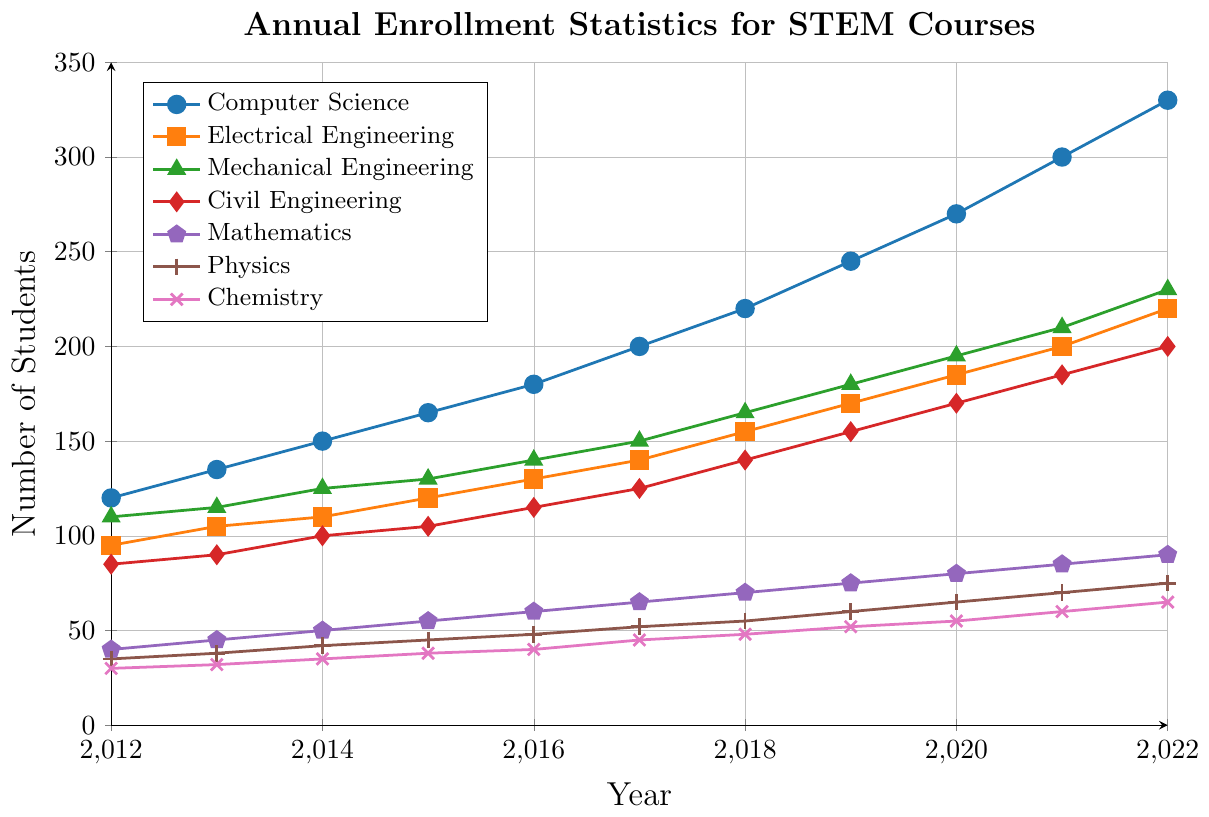Which course had the highest enrollment in 2022? By looking at the line corresponding to 2022, the line for Computer Science is the highest.
Answer: Computer Science How many more students enrolled in Computer Science than in Civil Engineering in 2022? In 2022, Computer Science had 330 students and Civil Engineering had 200 students. The difference is 330 - 200.
Answer: 130 Which course had the smallest increase in enrollment between 2012 and 2022? To determine the smallest increase, we compare the enrollment difference from 2012 to 2022 for all courses. Chemistry increased from 30 to 65, a 35-student increase, which is the smallest.
Answer: Chemistry What's the total enrollment for all courses in 2016? Sum the enrollment numbers for all courses in 2016: 180 (CS) + 130 (EE) + 140 (ME) + 115 (CE) + 60 (Math) + 48 (Physics) + 40 (Chemistry) = 713.
Answer: 713 Which course showed the most consistent increase in student enrollment over the years? By observing the plot lines, the Mathematics course shows a steady, consistent, and gradual increase each year from 2012 to 2022 with no spikes or drops.
Answer: Mathematics How many students were enrolled in Physics in 2020 compared to 2014? In 2020, Physics had 65 students, and in 2014, it had 42 students.
Answer: 65 Was there any year when enrollment in Electrical Engineering was equal to or less than 100? Observe the plot line for Electrical Engineering and see that in 2013 (105), the enrollment was closest but not below or equal to 100.
Answer: No What was the average enrollment for Mechanical Engineering from 2012 to 2022? Summing the Mechanical Engineering enrollment numbers from 2012 to 2022: 110 + 115 + 125 + 130 + 140 + 150 + 165 + 180 + 195 + 210 + 230 = 1750. Dividing by 11 years gives 1750 / 11.
Answer: ~159 Between 2012 and 2015, which course had the highest enrollment growth rate? Calculating the growth rate for each course between 2012 and 2015: Computer Science (165-120), Electrical Engineering (120-95), Mechanical Engineering (130-110), Civil Engineering (105-85), Mathematics (55-40), Physics (45-35), Chemistry (38-30). The Computer Science course had the largest increase (45).
Answer: Computer Science By how much did enrollment in Chemistry increase from 2017 to 2021? Enrollment in Chemistry in 2017 was 45, and in 2021 it was 60. The increase is 60 - 45.
Answer: 15 